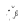<formula> <loc_0><loc_0><loc_500><loc_500>i ^ { \lambda _ { \pi } }</formula> 